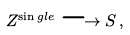<formula> <loc_0><loc_0><loc_500><loc_500>Z ^ { \sin g l e } \longrightarrow S \, ,</formula> 